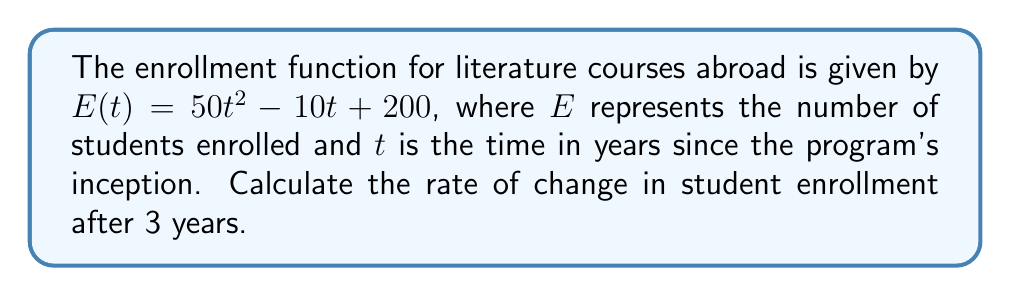Could you help me with this problem? To find the rate of change in student enrollment after 3 years, we need to calculate the derivative of the enrollment function $E(t)$ and then evaluate it at $t = 3$.

Step 1: Find the derivative of $E(t)$.
$$\frac{d}{dt}E(t) = \frac{d}{dt}(50t^2 - 10t + 200)$$
$$E'(t) = 100t - 10$$

Step 2: Evaluate $E'(t)$ at $t = 3$.
$$E'(3) = 100(3) - 10$$
$$E'(3) = 300 - 10 = 290$$

The rate of change in student enrollment after 3 years is 290 students per year.
Answer: 290 students/year 